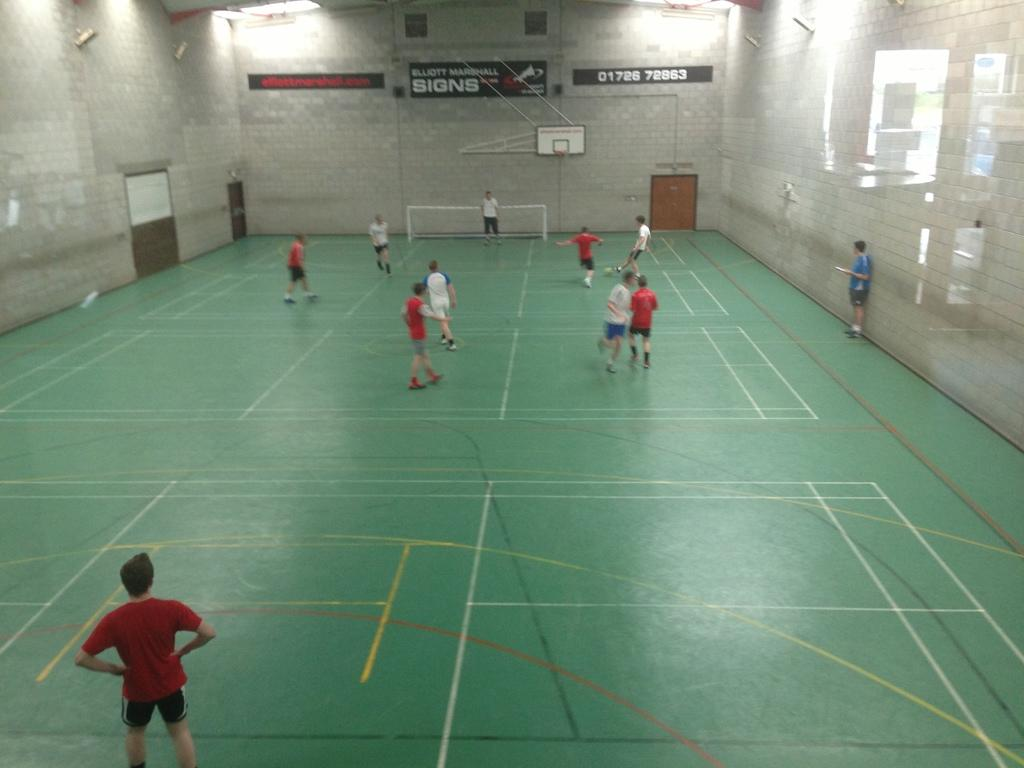How many people are present in the image? There are two people standing in the image. What are the two people doing in the image? The two people are players. What can be seen on the wall in the background of the image? There are boards on a wall in the background of the image. What is the purpose of the net visible in the background of the image? The net is likely used for the game or sport being played by the two people. Where can we find the nearest rail station to the location of the image? The provided facts do not mention a rail station or its location, so it cannot be determined from the image. 